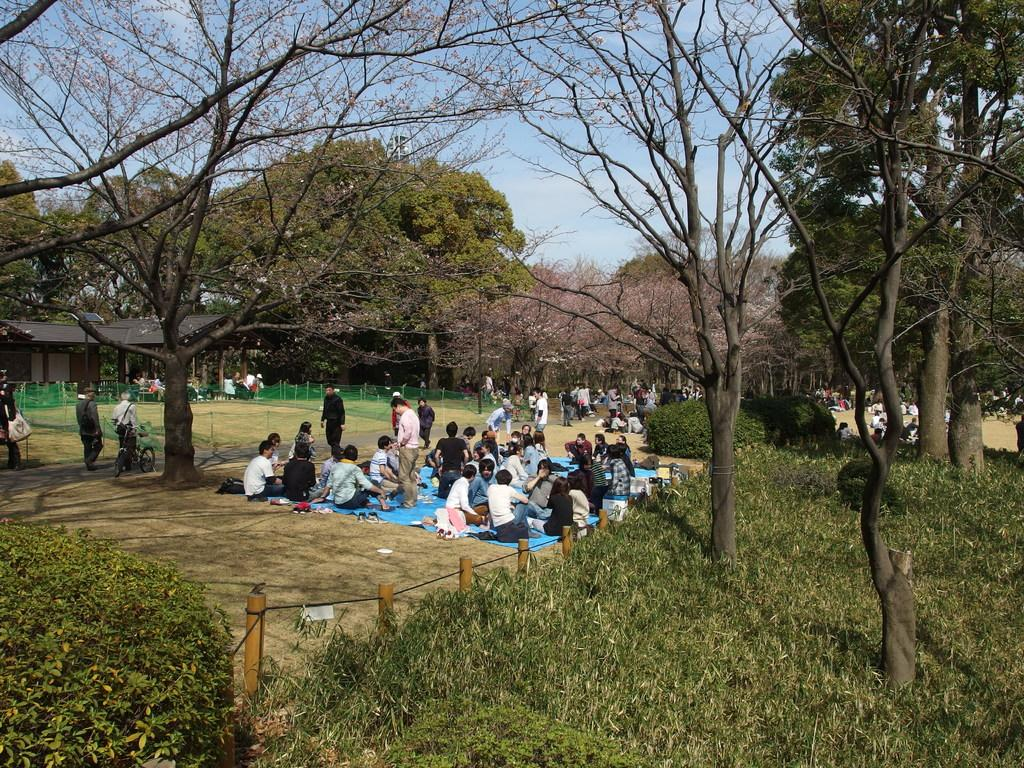How many people are in the image? There is a group of people in the image, but the exact number is not specified. What are some of the people in the image doing? Some of the people are sitting. What type of vegetation can be seen in the image? There are plants, trees, and sheds in the image. What is the background of the image? The sky is visible in the background of the image. What type of glove is being used by the creature in the image? There is no creature or glove present in the image. 